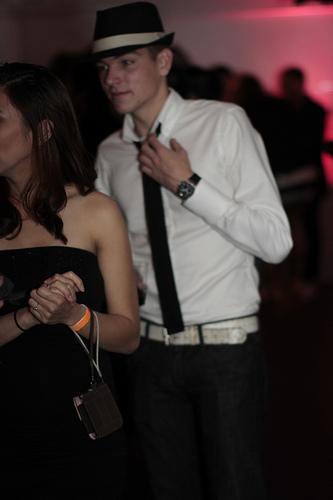How many people are wearing a hat in this photo?
Give a very brief answer. 1. 